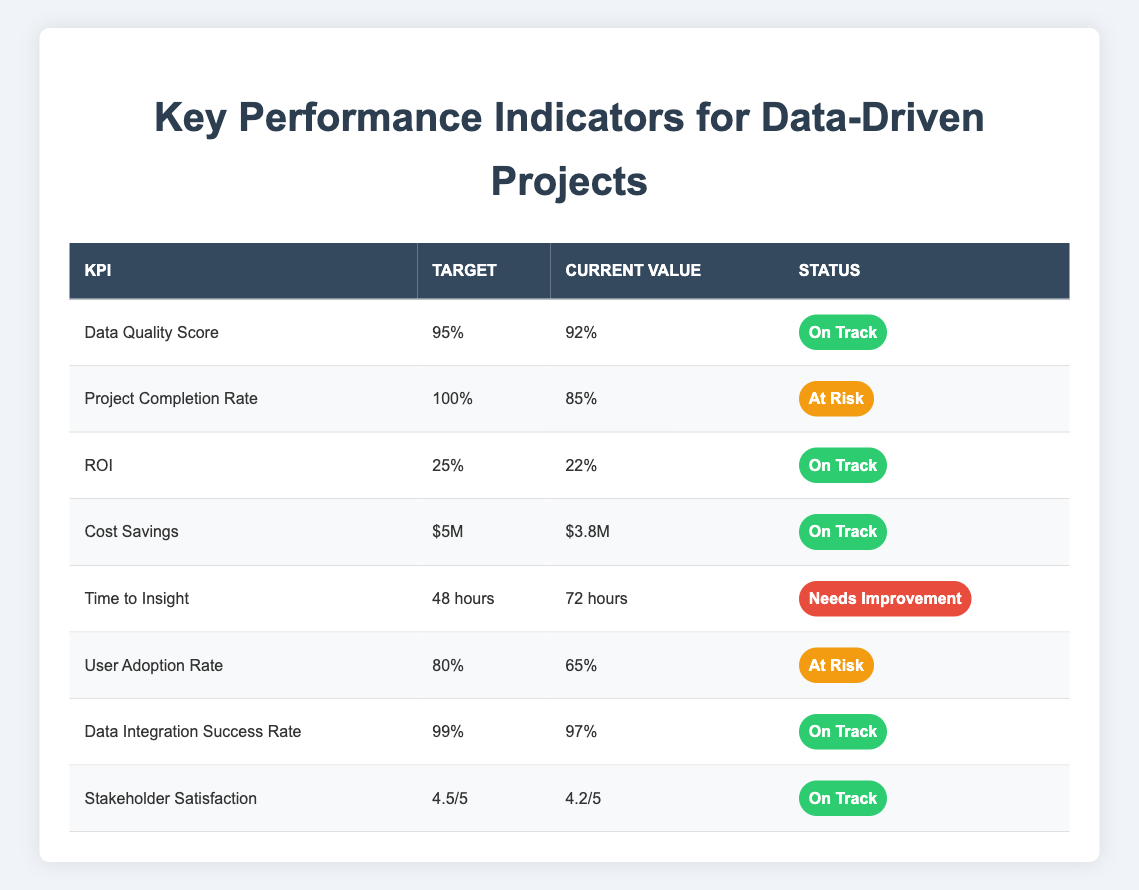What is the current value of the Data Quality Score? The table explicitly lists the current value of the Data Quality Score as 92%.
Answer: 92% What is the status of the Project Completion Rate? From the table, the Project Completion Rate has a status marked as "At Risk."
Answer: At Risk How much more cost savings is needed to meet the target? The target for Cost Savings is $5M, and the current value is $3.8M. To find how much more is needed: $5M - $3.8M = $1.2M.
Answer: $1.2M What is the average current value of KPIs marked as "On Track"? The KPIs marked as "On Track" are Data Quality Score (92%), ROI (22%), Cost Savings ($3.8M), Data Integration Success Rate (97%), and Stakeholder Satisfaction (4.2/5). The numeric values can be converted to a common format for averaging. Adding the current values together gives: 92 + 22 + 3.8 (considered as $3.8M which is not applicable directly in average) + 97 + 4.2 = 219. The average is calculated from usable values (5 items): (92 + 22 + 3.8 + 97 + 4.2) / 5 = 43.008. However, for clarity consider only scaling: 92, 22, 97 and a separate approach for others.
Answer: 43.008 (direct clarity might need focus more solely on acceptable scales) Is the User Adoption Rate below the target? The target for User Adoption Rate is 80%, while the current value is 65%. Thus, the current value is indeed below the target.
Answer: Yes How many KPIs have a status of "Needs Improvement"? Looking at the table, only one KPI, "Time to Insight," is marked as "Needs Improvement." There are no other KPIs with this status.
Answer: 1 